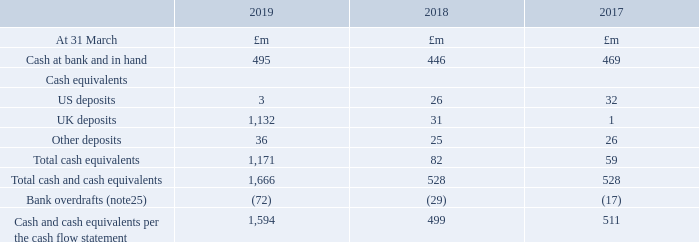24. Cash and cash equivalents
Significant accounting policies that apply to cash and cash equivalents Cash and cash equivalents comprise cash in hand and current balances with banks and similar institutions, which are readily convertible to cash and are subject to insignificant risk of changes in value and have an original maturity of three months or less. All are held at amortised cost on the balance sheet, equating to fair value. For the purpose of the consolidated cash flow statement, cash and cash equivalents are as defined above net of outstanding bank overdrafts. Bank overdrafts are included within the current element of loans and other borrowings (note 25).
IFRS 9 was applied for the first time on 1 April 2018 and introduces new classifications for financial instruments. Cash and cash equivalents were classified as loans and receivables under IAS 39, and are now classified as financial assets held at amortised cost under IFRS 9. This has not had an impact on the accounting for these instruments, or on their carrying amounts.
Cash and cash equivalents include restricted cash of £44m (2017/18: £32m, 2016/17: £43m), of which £40m (2017/18: £29m, 2016/17: £41m) was held in countries where local capital or exchange controls currently prevent us from accessing cash balances. The remaining balance of £4m (2017/18: £3m, 2016/17: £2m) was held in escrow accounts, or in commercial arrangements akin to escrow.
What was the cash at bank and in hand in 2019, 2018 and 2017?
Answer scale should be: million. 495, 446, 469. What was the balance held in escrow account in 2019? £4m. When was the IFRS 9 applied? 1 april 2018. What is the change in the Cash at bank and in hand from 2018 to 2019?
Answer scale should be: million. 495 - 446
Answer: 49. What is the average US deposits for 2017-2019?
Answer scale should be: million. (3 + 26 + 32) / 3
Answer: 20.33. For which year(s) are the Total cash and cash equivalents lower than 1,000 million?
Answer scale should be: million. Locate total cash and cash equivalents in row 9 and analyse
answer: 2018, 2017. 